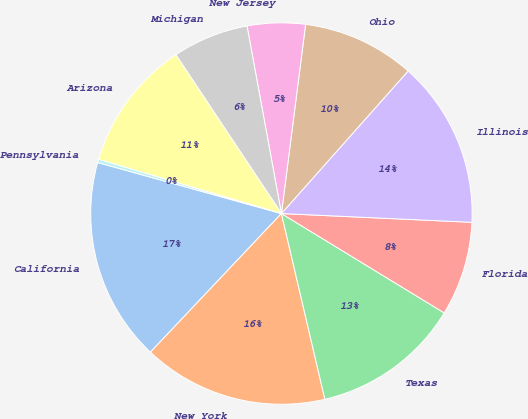Convert chart. <chart><loc_0><loc_0><loc_500><loc_500><pie_chart><fcel>California<fcel>New York<fcel>Texas<fcel>Florida<fcel>Illinois<fcel>Ohio<fcel>New Jersey<fcel>Michigan<fcel>Arizona<fcel>Pennsylvania<nl><fcel>17.26%<fcel>15.71%<fcel>12.62%<fcel>7.99%<fcel>14.17%<fcel>9.54%<fcel>4.91%<fcel>6.45%<fcel>11.08%<fcel>0.27%<nl></chart> 